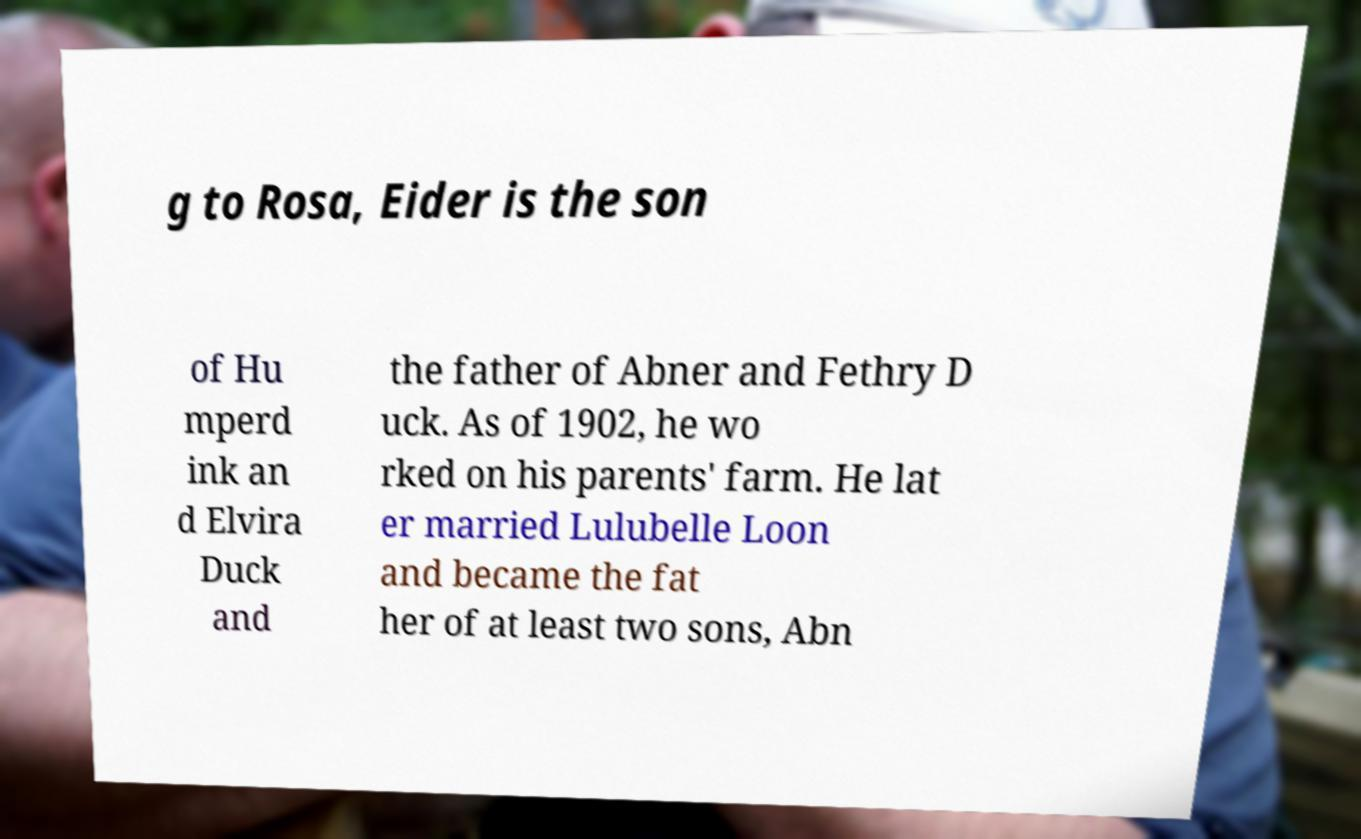Please identify and transcribe the text found in this image. g to Rosa, Eider is the son of Hu mperd ink an d Elvira Duck and the father of Abner and Fethry D uck. As of 1902, he wo rked on his parents' farm. He lat er married Lulubelle Loon and became the fat her of at least two sons, Abn 